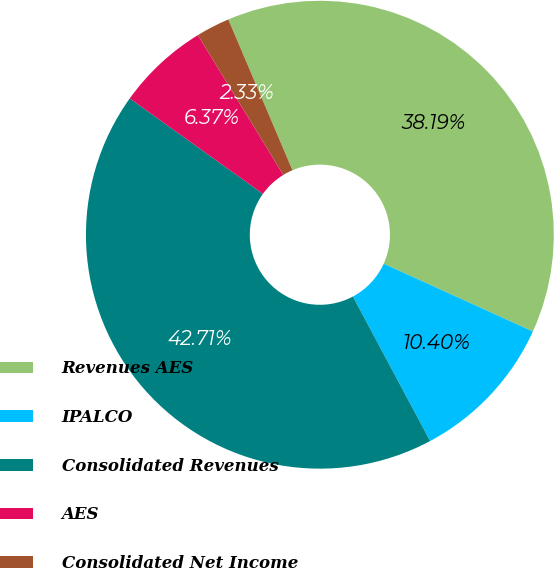Convert chart. <chart><loc_0><loc_0><loc_500><loc_500><pie_chart><fcel>Revenues AES<fcel>IPALCO<fcel>Consolidated Revenues<fcel>AES<fcel>Consolidated Net Income<nl><fcel>38.19%<fcel>10.4%<fcel>42.71%<fcel>6.37%<fcel>2.33%<nl></chart> 